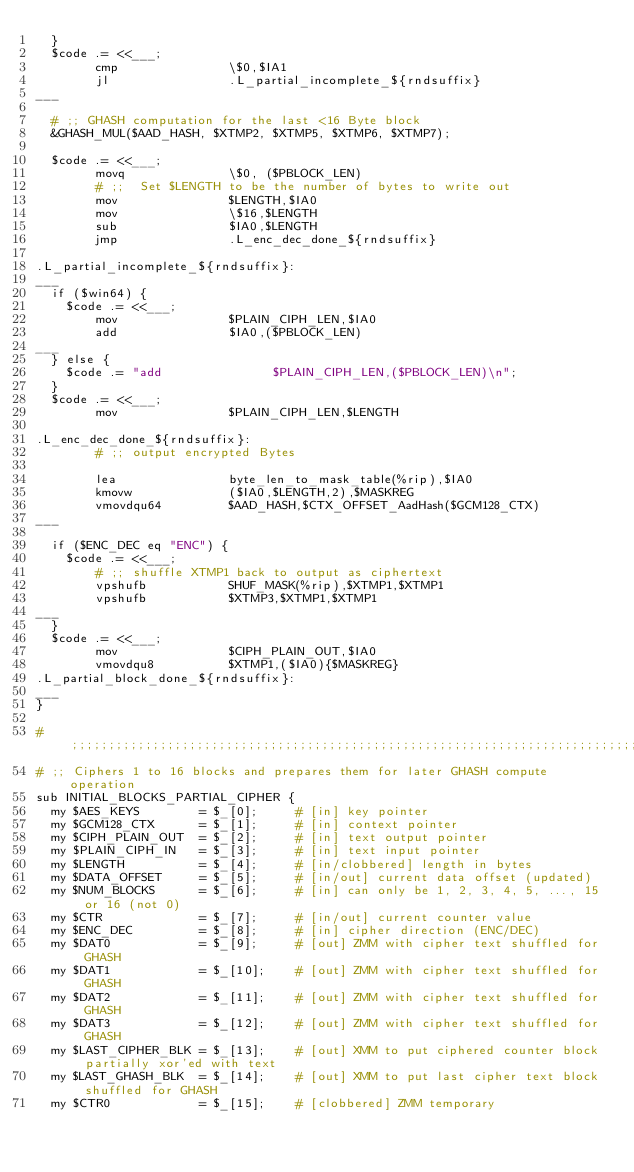<code> <loc_0><loc_0><loc_500><loc_500><_Perl_>  }
  $code .= <<___;
        cmp               \$0,$IA1
        jl                .L_partial_incomplete_${rndsuffix}
___

  # ;; GHASH computation for the last <16 Byte block
  &GHASH_MUL($AAD_HASH, $XTMP2, $XTMP5, $XTMP6, $XTMP7);

  $code .= <<___;
        movq              \$0, ($PBLOCK_LEN)
        # ;;  Set $LENGTH to be the number of bytes to write out
        mov               $LENGTH,$IA0
        mov               \$16,$LENGTH
        sub               $IA0,$LENGTH
        jmp               .L_enc_dec_done_${rndsuffix}

.L_partial_incomplete_${rndsuffix}:
___
  if ($win64) {
    $code .= <<___;
        mov               $PLAIN_CIPH_LEN,$IA0
        add               $IA0,($PBLOCK_LEN)
___
  } else {
    $code .= "add               $PLAIN_CIPH_LEN,($PBLOCK_LEN)\n";
  }
  $code .= <<___;
        mov               $PLAIN_CIPH_LEN,$LENGTH

.L_enc_dec_done_${rndsuffix}:
        # ;; output encrypted Bytes

        lea               byte_len_to_mask_table(%rip),$IA0
        kmovw             ($IA0,$LENGTH,2),$MASKREG
        vmovdqu64         $AAD_HASH,$CTX_OFFSET_AadHash($GCM128_CTX)
___

  if ($ENC_DEC eq "ENC") {
    $code .= <<___;
        # ;; shuffle XTMP1 back to output as ciphertext
        vpshufb           SHUF_MASK(%rip),$XTMP1,$XTMP1
        vpshufb           $XTMP3,$XTMP1,$XTMP1
___
  }
  $code .= <<___;
        mov               $CIPH_PLAIN_OUT,$IA0
        vmovdqu8          $XTMP1,($IA0){$MASKREG}
.L_partial_block_done_${rndsuffix}:
___
}

# ;;;;;;;;;;;;;;;;;;;;;;;;;;;;;;;;;;;;;;;;;;;;;;;;;;;;;;;;;;;;;;;;;;;;;;;;;;;;;;
# ;; Ciphers 1 to 16 blocks and prepares them for later GHASH compute operation
sub INITIAL_BLOCKS_PARTIAL_CIPHER {
  my $AES_KEYS        = $_[0];     # [in] key pointer
  my $GCM128_CTX      = $_[1];     # [in] context pointer
  my $CIPH_PLAIN_OUT  = $_[2];     # [in] text output pointer
  my $PLAIN_CIPH_IN   = $_[3];     # [in] text input pointer
  my $LENGTH          = $_[4];     # [in/clobbered] length in bytes
  my $DATA_OFFSET     = $_[5];     # [in/out] current data offset (updated)
  my $NUM_BLOCKS      = $_[6];     # [in] can only be 1, 2, 3, 4, 5, ..., 15 or 16 (not 0)
  my $CTR             = $_[7];     # [in/out] current counter value
  my $ENC_DEC         = $_[8];     # [in] cipher direction (ENC/DEC)
  my $DAT0            = $_[9];     # [out] ZMM with cipher text shuffled for GHASH
  my $DAT1            = $_[10];    # [out] ZMM with cipher text shuffled for GHASH
  my $DAT2            = $_[11];    # [out] ZMM with cipher text shuffled for GHASH
  my $DAT3            = $_[12];    # [out] ZMM with cipher text shuffled for GHASH
  my $LAST_CIPHER_BLK = $_[13];    # [out] XMM to put ciphered counter block partially xor'ed with text
  my $LAST_GHASH_BLK  = $_[14];    # [out] XMM to put last cipher text block shuffled for GHASH
  my $CTR0            = $_[15];    # [clobbered] ZMM temporary</code> 